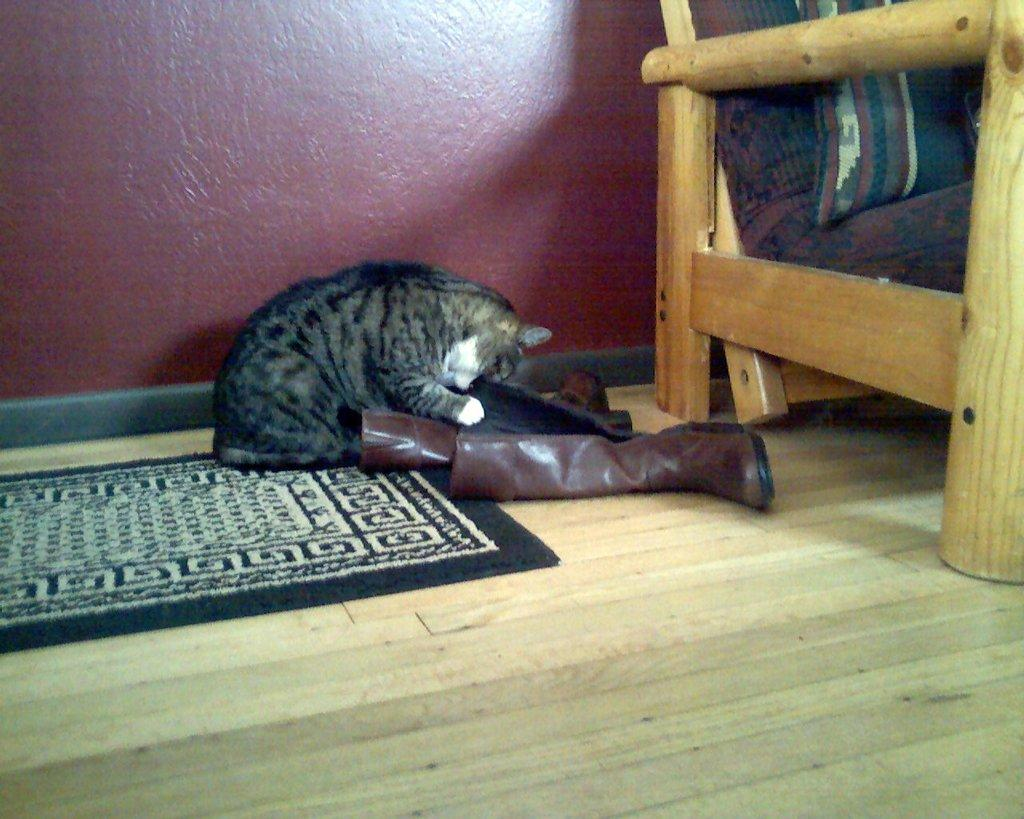What animal can be seen sitting in the image? There is a cat sitting in the image. What is the cat doing with its mouth? The cat is holding a footwear with its mouth. Can you describe the footwear visible in the image? There is a footwear visible on the floor. What type of surface is on the floor? There is a mat on the floor. What type of furniture is in the image? There is a chair in the image. What is the background of the image? There is a wall in the image. How many cherries are on the goat's head in the image? There is no goat or cherries present in the image. What type of calculator is on the chair in the image? There is no calculator present in the image. 